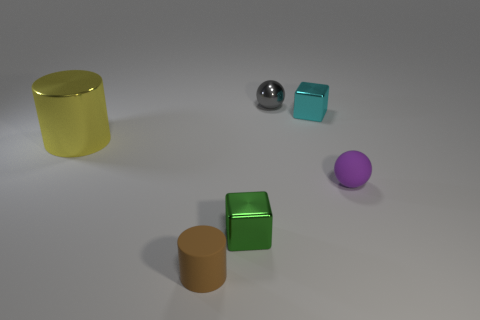Add 2 large gray matte spheres. How many objects exist? 8 Subtract all spheres. How many objects are left? 4 Add 5 tiny shiny spheres. How many tiny shiny spheres exist? 6 Subtract 1 cyan cubes. How many objects are left? 5 Subtract all cylinders. Subtract all cyan metallic objects. How many objects are left? 3 Add 3 tiny metallic blocks. How many tiny metallic blocks are left? 5 